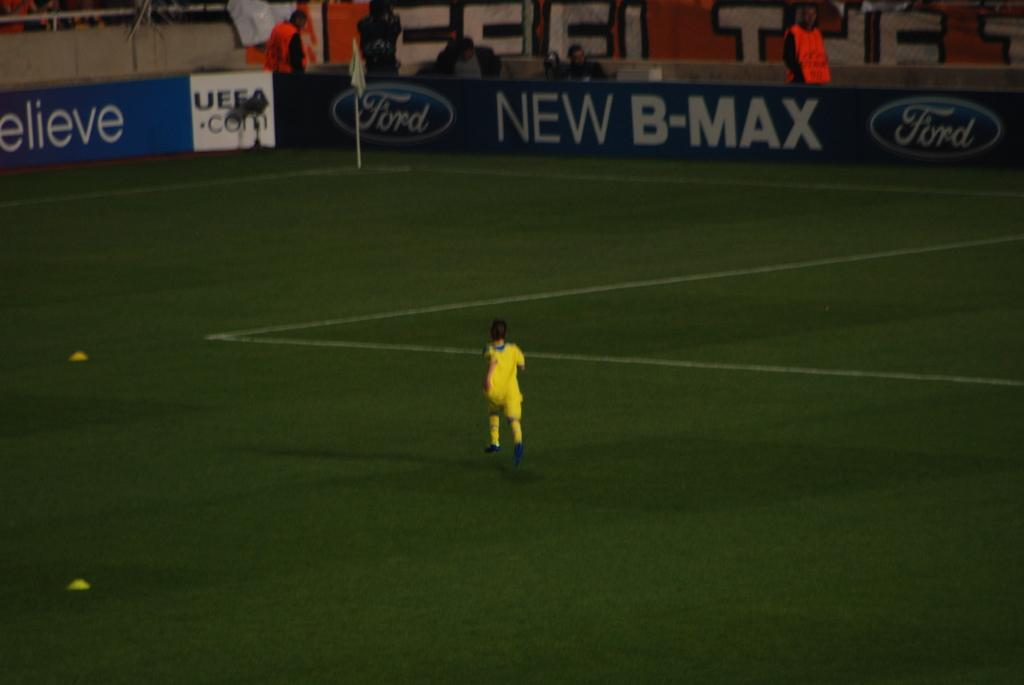Provide a one-sentence caption for the provided image. A person dressed in yellow running on the field of the New B-Max field. 